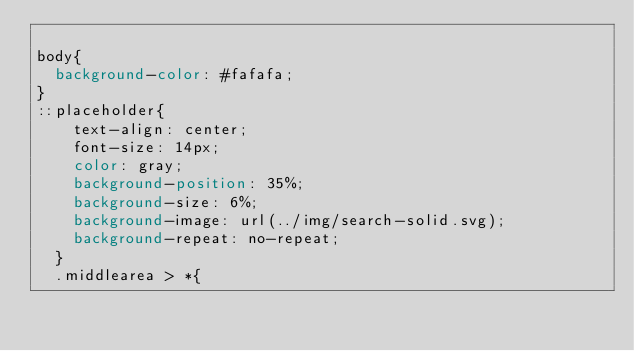<code> <loc_0><loc_0><loc_500><loc_500><_CSS_>
body{
  background-color: #fafafa;
}
::placeholder{
    text-align: center;
    font-size: 14px;
    color: gray;
    background-position: 35%;
    background-size: 6%;
    background-image: url(../img/search-solid.svg);
    background-repeat: no-repeat;
  }
  .middlearea > *{</code> 